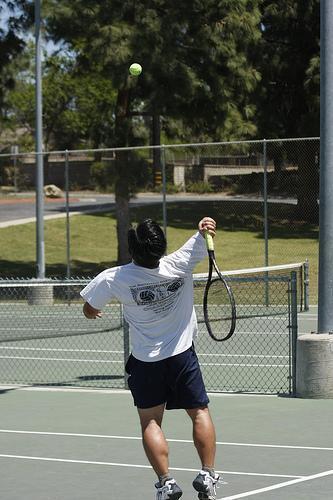How many people are in the photo?
Give a very brief answer. 1. 